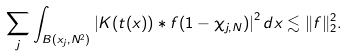Convert formula to latex. <formula><loc_0><loc_0><loc_500><loc_500>\sum _ { j } \int _ { B ( x _ { j } , N ^ { 2 } ) } \left | K ( t ( x ) ) \ast f ( 1 - \chi _ { j , N } ) \right | ^ { 2 } d x \lesssim \| f \| _ { 2 } ^ { 2 } .</formula> 